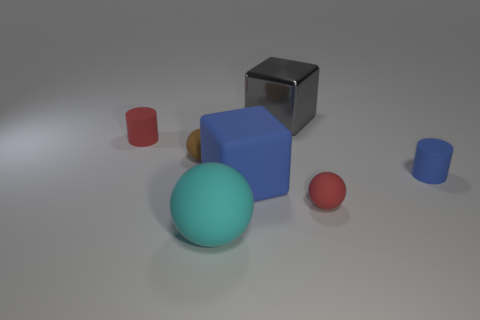Add 1 red matte objects. How many objects exist? 8 Subtract all cylinders. How many objects are left? 5 Add 2 tiny yellow objects. How many tiny yellow objects exist? 2 Subtract 1 gray cubes. How many objects are left? 6 Subtract all big blue matte cubes. Subtract all brown spheres. How many objects are left? 5 Add 1 tiny spheres. How many tiny spheres are left? 3 